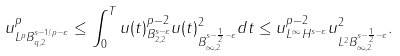<formula> <loc_0><loc_0><loc_500><loc_500>\| u \| ^ { p } _ { L ^ { p } B ^ { s - 1 / p - \varepsilon } _ { q , 2 } } \leq \int _ { 0 } ^ { T } \| u ( t ) \| _ { B ^ { s - \varepsilon } _ { 2 , 2 } } ^ { p - 2 } \| u ( t ) \| _ { B ^ { s - \frac { 1 } { 2 } - \varepsilon } _ { \infty , 2 } } ^ { 2 } d t \leq \| u \| _ { L ^ { \infty } H ^ { s - \varepsilon } } ^ { p - 2 } \| u \| _ { L ^ { 2 } B ^ { s - \frac { 1 } { 2 } - \varepsilon } _ { \infty , 2 } } ^ { 2 } .</formula> 